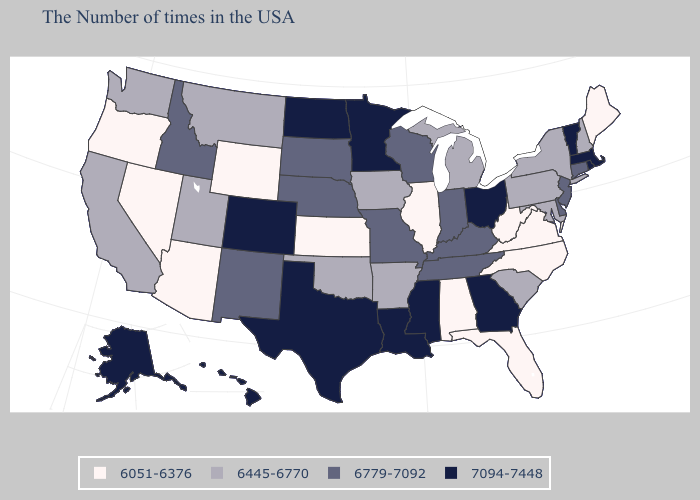Name the states that have a value in the range 6779-7092?
Write a very short answer. Connecticut, New Jersey, Delaware, Kentucky, Indiana, Tennessee, Wisconsin, Missouri, Nebraska, South Dakota, New Mexico, Idaho. Name the states that have a value in the range 6445-6770?
Write a very short answer. New Hampshire, New York, Maryland, Pennsylvania, South Carolina, Michigan, Arkansas, Iowa, Oklahoma, Utah, Montana, California, Washington. Does Oregon have the lowest value in the USA?
Write a very short answer. Yes. Which states have the lowest value in the Northeast?
Be succinct. Maine. What is the highest value in the USA?
Keep it brief. 7094-7448. Among the states that border Minnesota , does North Dakota have the lowest value?
Concise answer only. No. What is the highest value in the West ?
Concise answer only. 7094-7448. Which states hav the highest value in the MidWest?
Answer briefly. Ohio, Minnesota, North Dakota. Among the states that border Iowa , does Minnesota have the highest value?
Write a very short answer. Yes. Name the states that have a value in the range 6445-6770?
Concise answer only. New Hampshire, New York, Maryland, Pennsylvania, South Carolina, Michigan, Arkansas, Iowa, Oklahoma, Utah, Montana, California, Washington. Does Mississippi have the lowest value in the South?
Answer briefly. No. Among the states that border North Carolina , which have the highest value?
Short answer required. Georgia. Does Alaska have the lowest value in the USA?
Keep it brief. No. What is the value of Michigan?
Give a very brief answer. 6445-6770. What is the value of California?
Be succinct. 6445-6770. 